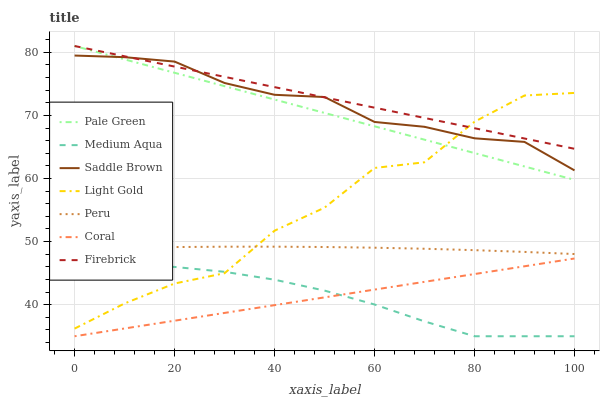Does Medium Aqua have the minimum area under the curve?
Answer yes or no. Yes. Does Firebrick have the maximum area under the curve?
Answer yes or no. Yes. Does Pale Green have the minimum area under the curve?
Answer yes or no. No. Does Pale Green have the maximum area under the curve?
Answer yes or no. No. Is Coral the smoothest?
Answer yes or no. Yes. Is Light Gold the roughest?
Answer yes or no. Yes. Is Firebrick the smoothest?
Answer yes or no. No. Is Firebrick the roughest?
Answer yes or no. No. Does Pale Green have the lowest value?
Answer yes or no. No. Does Medium Aqua have the highest value?
Answer yes or no. No. Is Coral less than Firebrick?
Answer yes or no. Yes. Is Saddle Brown greater than Coral?
Answer yes or no. Yes. Does Coral intersect Firebrick?
Answer yes or no. No. 